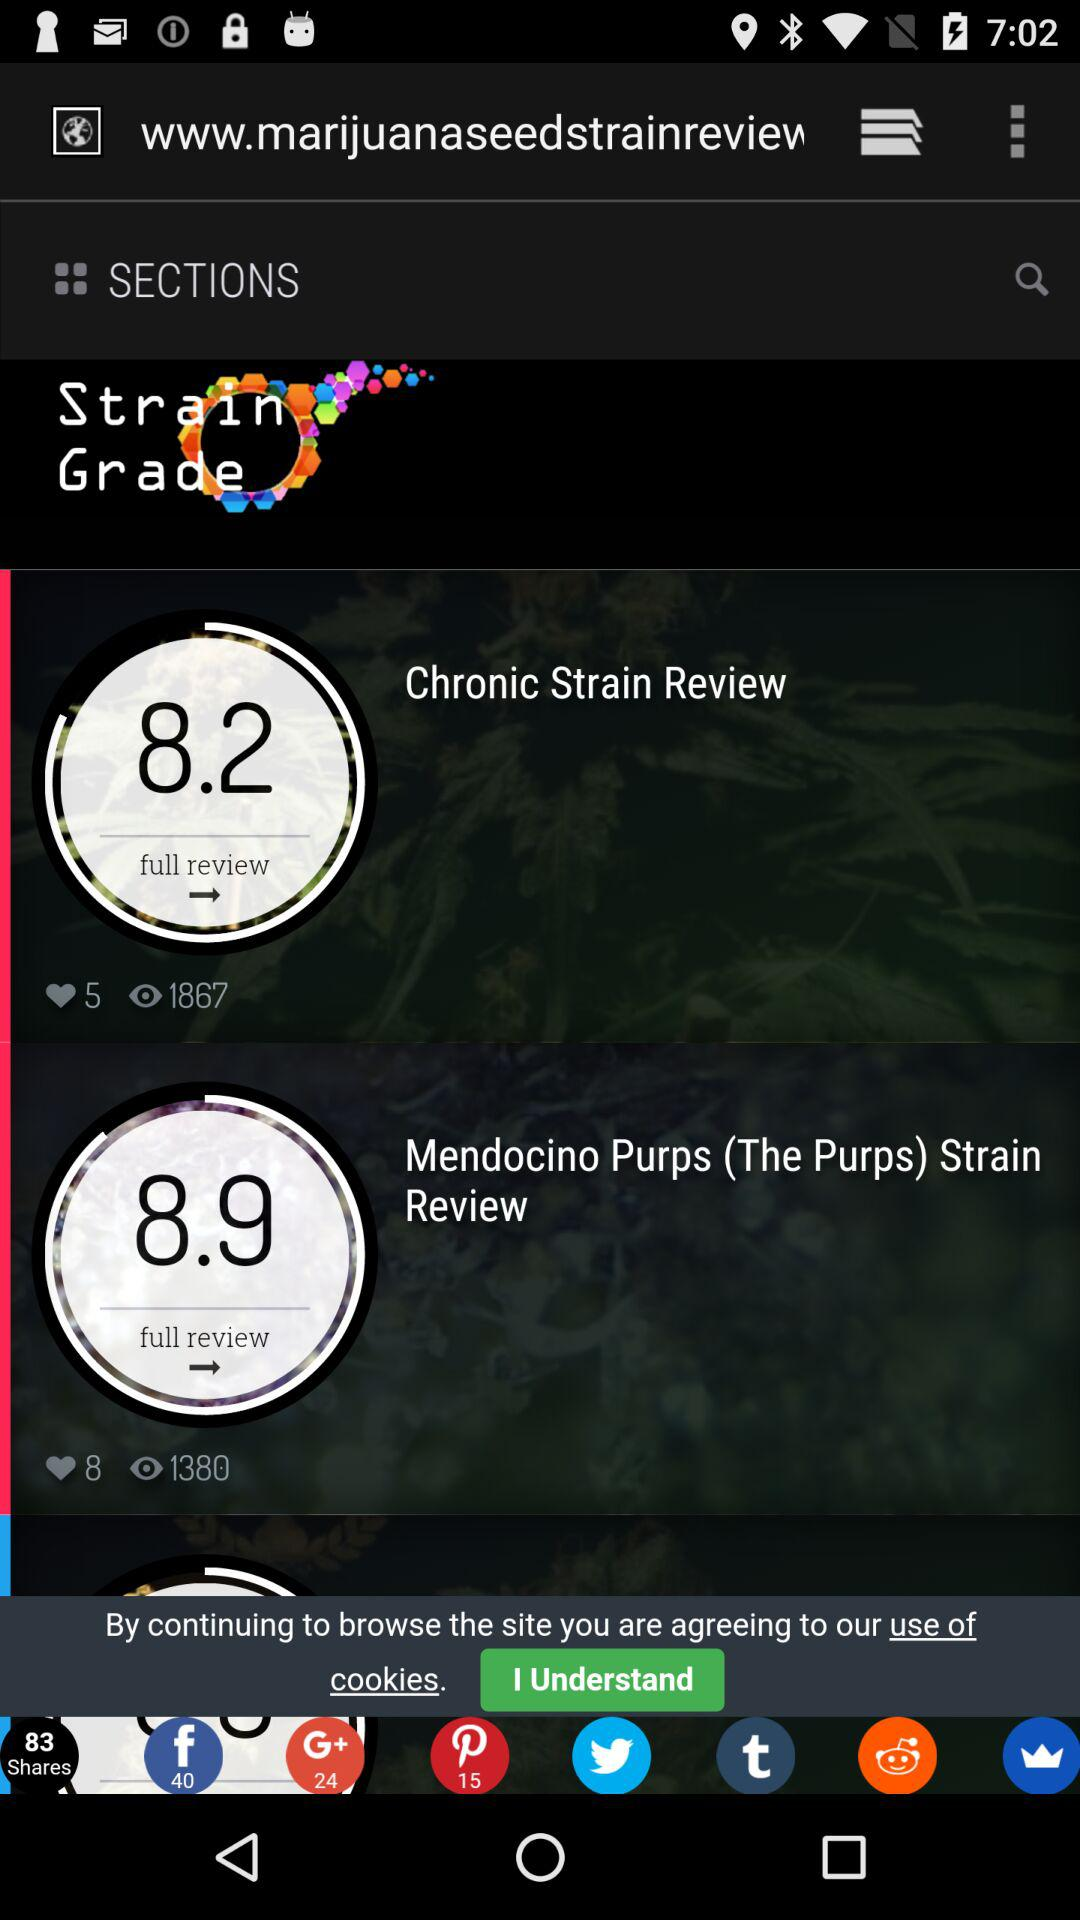What is the number of likes on the chronic strain review? There are 5 likes. 